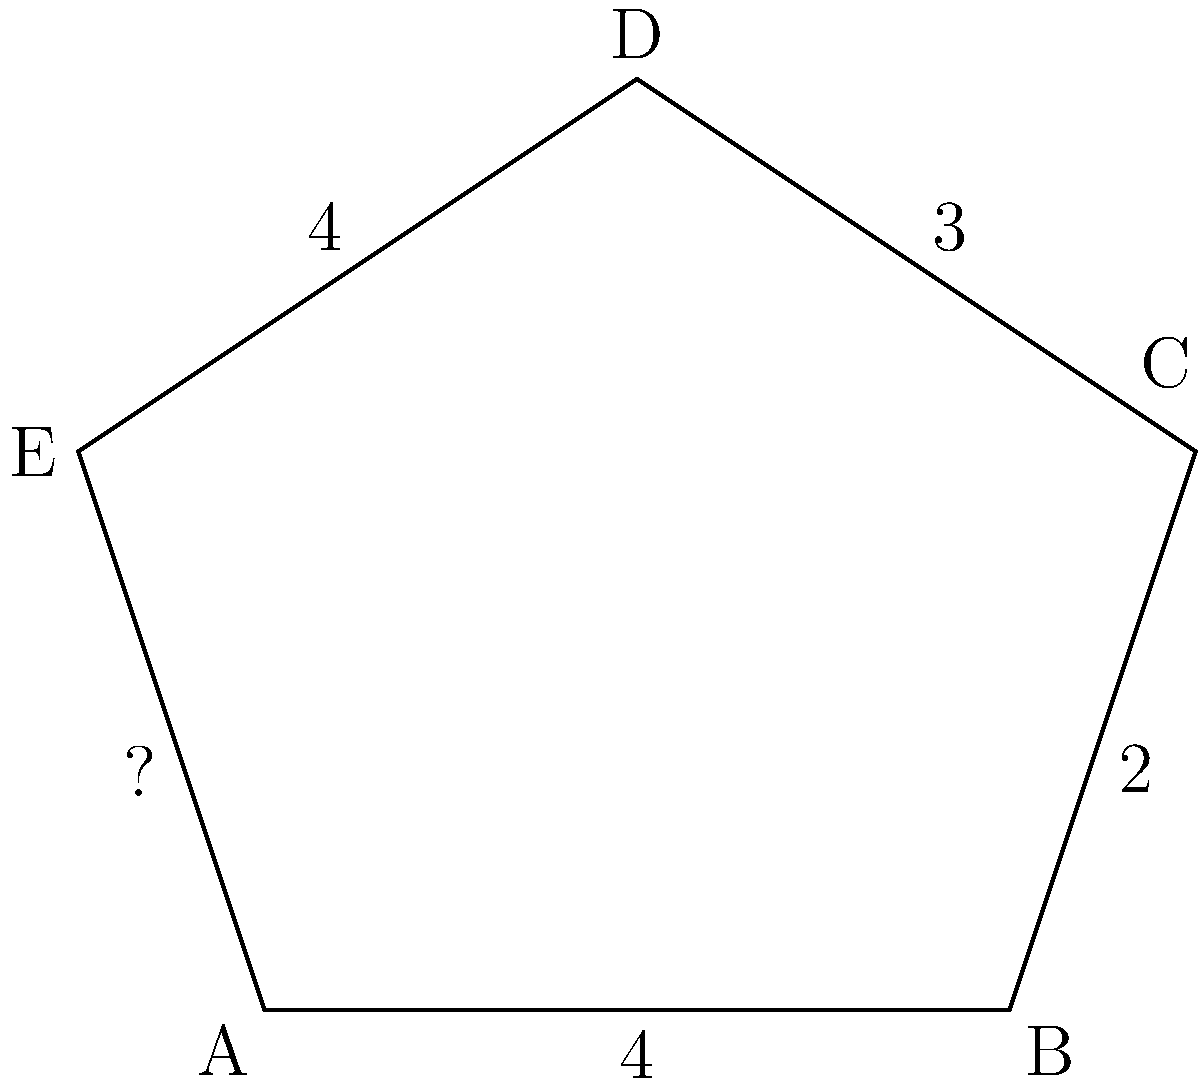You've found a unique pentagonal-shaped property lot in New York City. The real estate agent has provided you with the measurements of four sides: 4 units, 2 units, 3 units, and 4 units, as shown in the diagram. What is the length of the fifth side, and what is the total perimeter of the property? Let's approach this step-by-step:

1) First, we need to find the length of the unknown side. We can do this by using the property that the sum of all sides in a pentagon is equal to its perimeter.

2) Let's call the unknown side length $x$.

3) We know four sides: 4, 2, 3, and 4 units.

4) The perimeter of the pentagon can be expressed as:
   $4 + 2 + 3 + 4 + x = \text{Perimeter}$

5) We don't know the perimeter yet, but we can set up an equation based on the fact that the sum of all sides equals the perimeter:
   $4 + 2 + 3 + 4 + x = \text{Perimeter}$

6) Simplifying the left side:
   $13 + x = \text{Perimeter}$

7) Now, the unknown side length $x$ is also part of the perimeter. So we can write:
   $x = \text{Perimeter} - 13$

8) Substituting this into our original equation:
   $13 + (\text{Perimeter} - 13) = \text{Perimeter}$

9) Simplifying:
   $\text{Perimeter} = \text{Perimeter}$

10) This equation is always true, which means our assumption was correct. The unknown side length is indeed $\text{Perimeter} - 13$.

11) To find the actual length, we need to calculate the perimeter:
    $\text{Perimeter} = 4 + 2 + 3 + 4 + (\text{Perimeter} - 13)$

12) Solving for Perimeter:
    $13 + \text{Perimeter} - 13 = \text{Perimeter}$
    $\text{Perimeter} = 13$

13) Now we can calculate the unknown side length:
    $x = \text{Perimeter} - 13 = 13 - 13 = 0$

Therefore, the length of the fifth side is 0 units, and the total perimeter of the property is 13 units.
Answer: Fifth side: 0 units, Perimeter: 13 units 